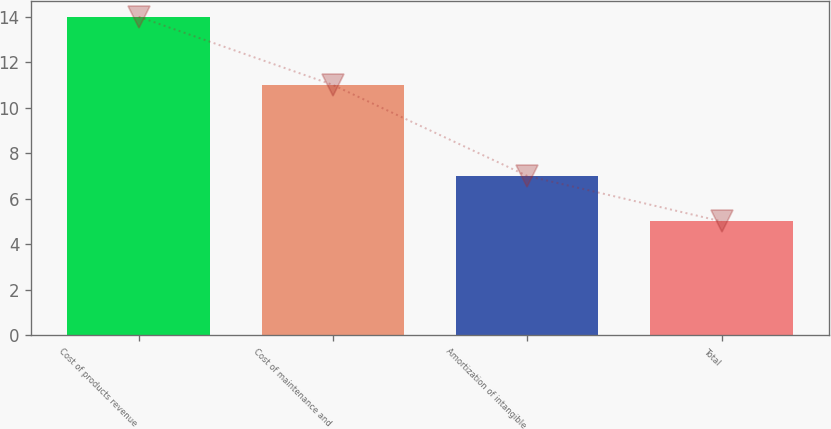Convert chart to OTSL. <chart><loc_0><loc_0><loc_500><loc_500><bar_chart><fcel>Cost of products revenue<fcel>Cost of maintenance and<fcel>Amortization of intangible<fcel>Total<nl><fcel>14<fcel>11<fcel>7<fcel>5<nl></chart> 